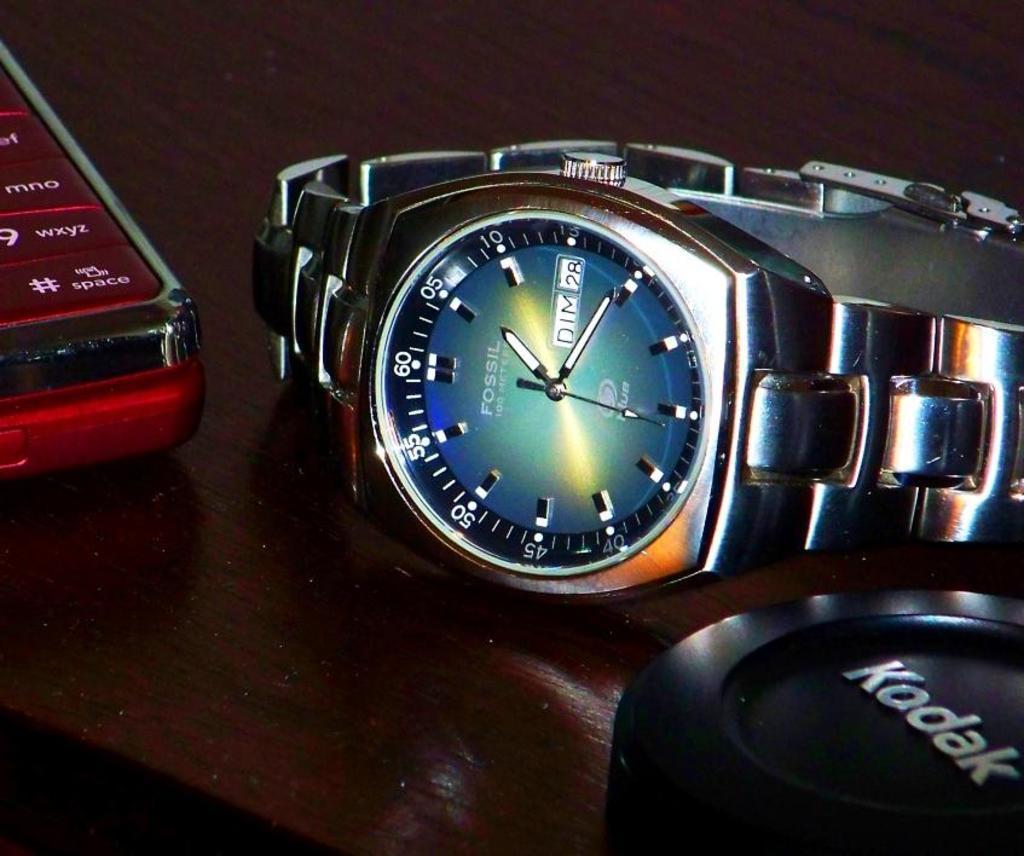How would you summarize this image in a sentence or two? In the picture I can see a table which has a fossil watch,mobile phone and a black color object on it. 